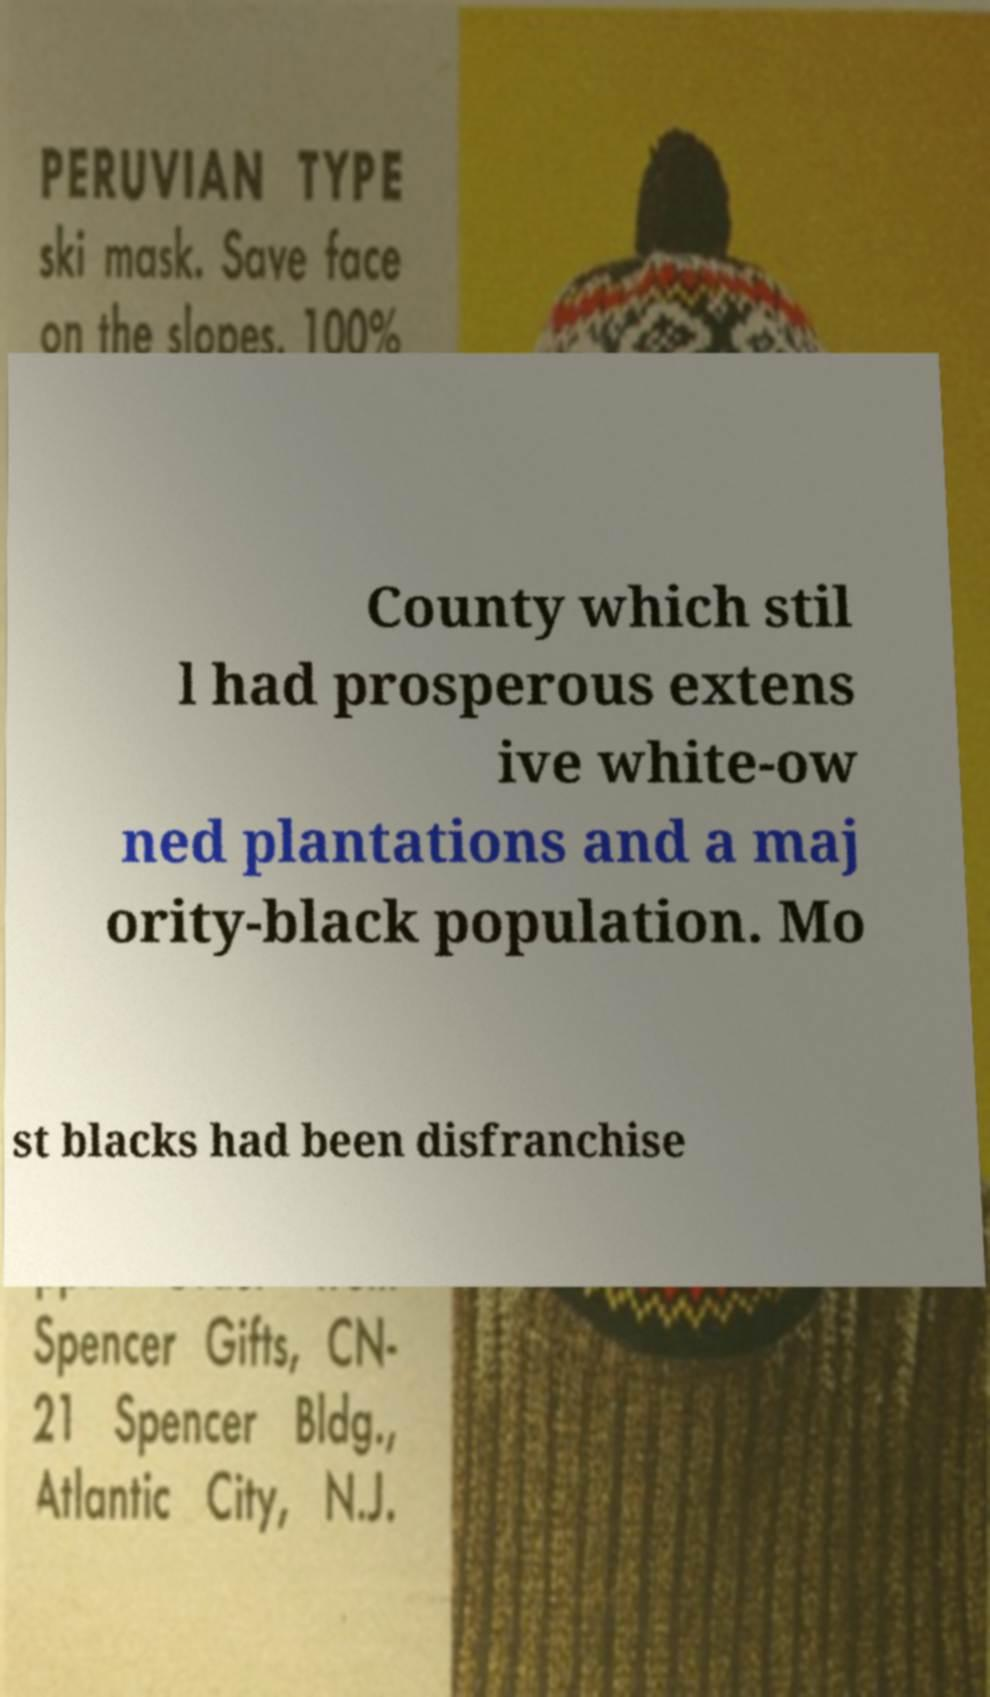Could you assist in decoding the text presented in this image and type it out clearly? County which stil l had prosperous extens ive white-ow ned plantations and a maj ority-black population. Mo st blacks had been disfranchise 